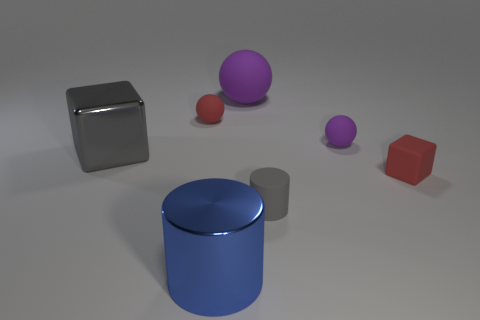Subtract all small matte balls. How many balls are left? 1 Subtract all cubes. How many objects are left? 5 Add 2 big cyan matte objects. How many objects exist? 9 Subtract all purple spheres. How many spheres are left? 1 Subtract all brown spheres. How many blue cubes are left? 0 Subtract all tiny purple things. Subtract all big cylinders. How many objects are left? 5 Add 1 large rubber spheres. How many large rubber spheres are left? 2 Add 7 large shiny cubes. How many large shiny cubes exist? 8 Subtract 1 gray blocks. How many objects are left? 6 Subtract all blue cylinders. Subtract all red balls. How many cylinders are left? 1 